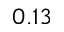<formula> <loc_0><loc_0><loc_500><loc_500>0 . 1 3</formula> 